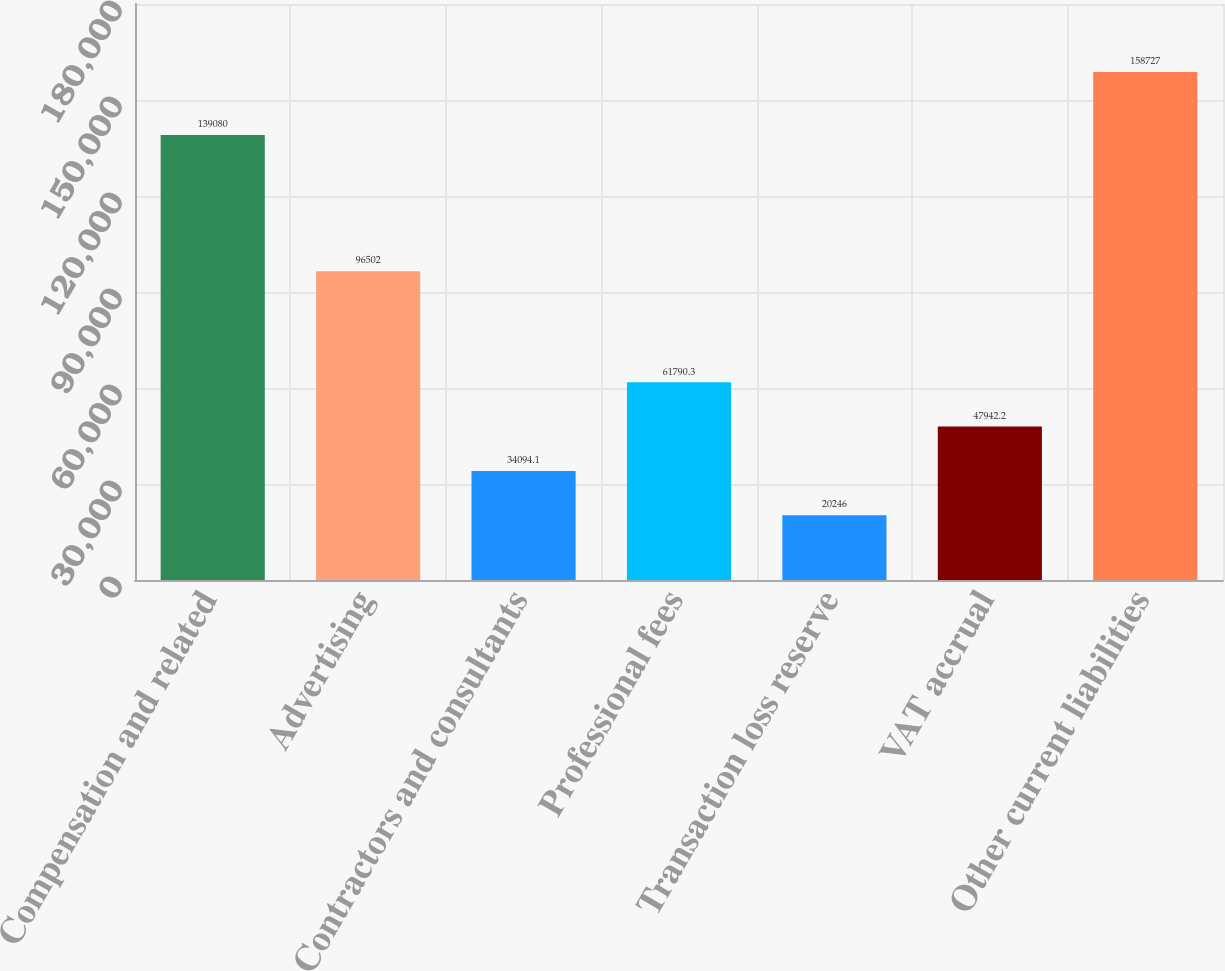Convert chart to OTSL. <chart><loc_0><loc_0><loc_500><loc_500><bar_chart><fcel>Compensation and related<fcel>Advertising<fcel>Contractors and consultants<fcel>Professional fees<fcel>Transaction loss reserve<fcel>VAT accrual<fcel>Other current liabilities<nl><fcel>139080<fcel>96502<fcel>34094.1<fcel>61790.3<fcel>20246<fcel>47942.2<fcel>158727<nl></chart> 